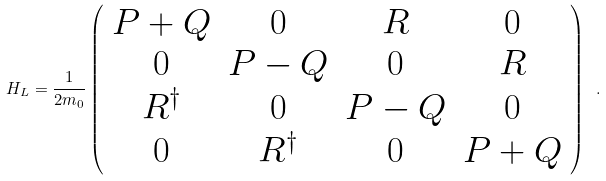<formula> <loc_0><loc_0><loc_500><loc_500>H _ { L } = \frac { 1 } { 2 m _ { 0 } } \left ( \begin{array} { c c c c } P + Q & 0 & R & 0 \\ 0 & P - Q & 0 & R \\ R ^ { \dag } & 0 & P - Q & 0 \\ 0 & R ^ { \dag } & 0 & P + Q \end{array} \right ) \ .</formula> 